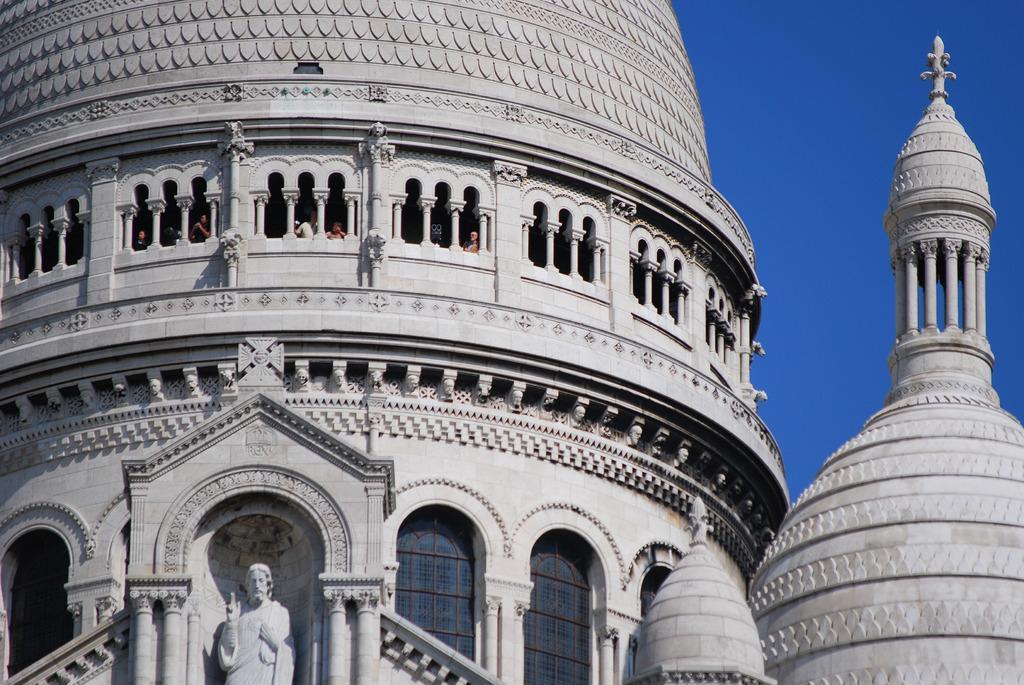Can you describe this image briefly? In the picture we can see a part of the historical building with an architect and a sculpture on it and beside it also we can see a part of the historical building and behind it we can see a part of the sky. 